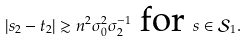Convert formula to latex. <formula><loc_0><loc_0><loc_500><loc_500>| s _ { 2 } - t _ { 2 } | \gtrsim n ^ { 2 } \sigma _ { 0 } ^ { 2 } \sigma _ { 2 } ^ { - 1 } \text { for } s \in \mathcal { S } _ { 1 } .</formula> 